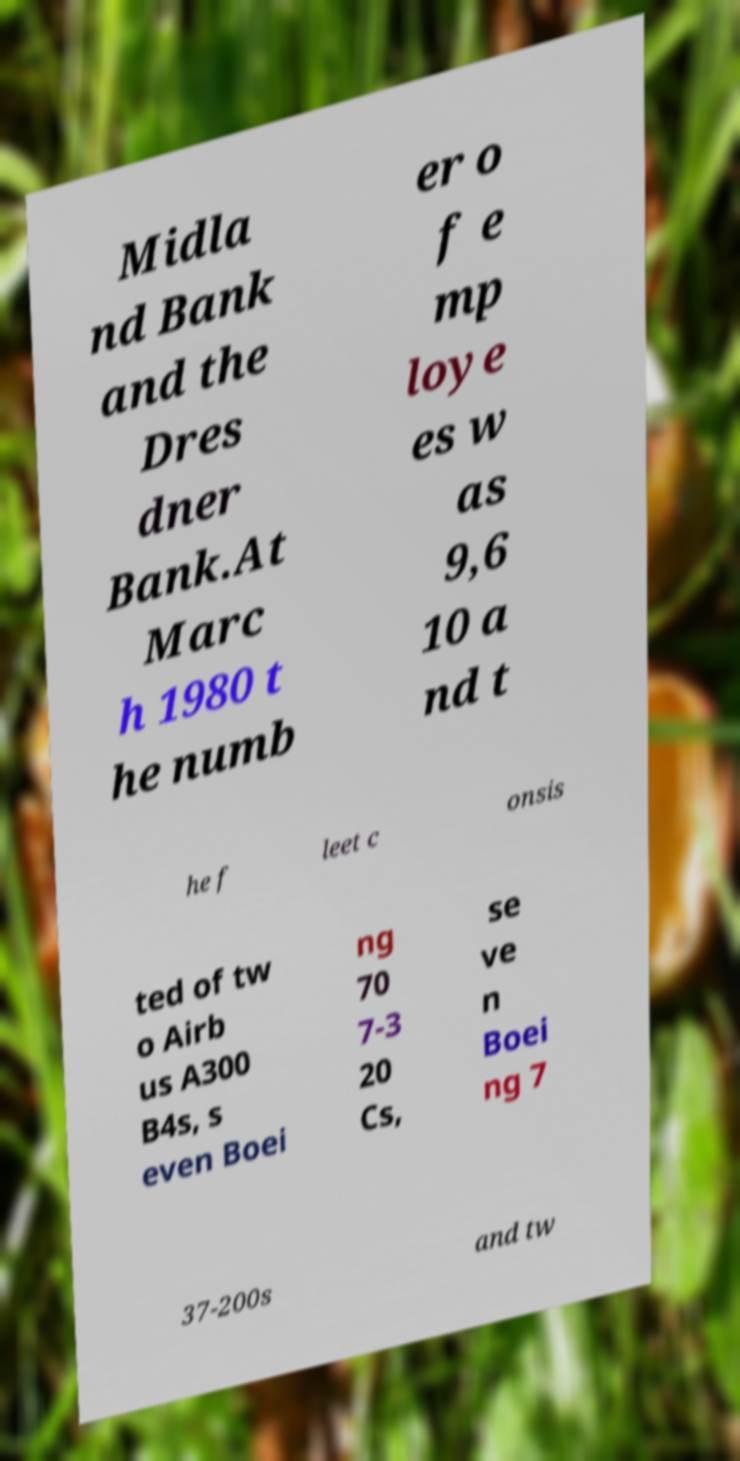There's text embedded in this image that I need extracted. Can you transcribe it verbatim? Midla nd Bank and the Dres dner Bank.At Marc h 1980 t he numb er o f e mp loye es w as 9,6 10 a nd t he f leet c onsis ted of tw o Airb us A300 B4s, s even Boei ng 70 7-3 20 Cs, se ve n Boei ng 7 37-200s and tw 